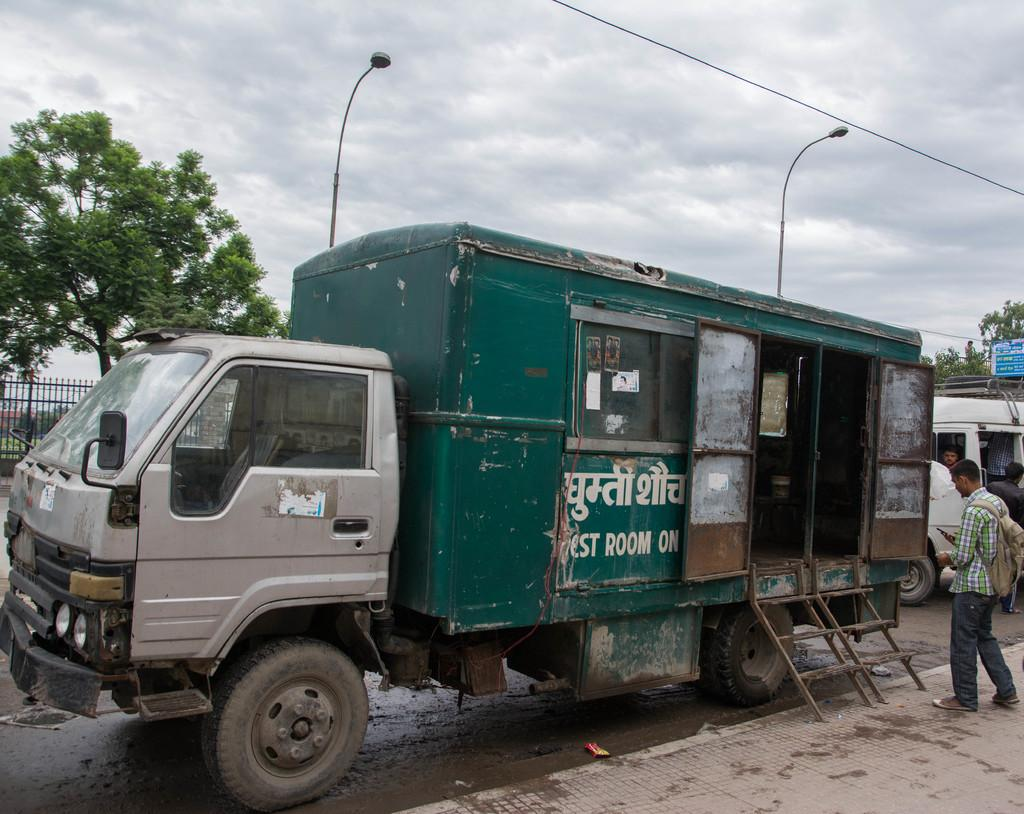What is the condition of the sky in the image? The sky is cloudy in the image. What structures can be seen along the road in the image? There are light poles in the image. What types of transportation are present on the road? Vehicles are present on the road. Can you identify any living beings in the image? People are visible in the image. What type of natural scenery is visible in the background? There are trees in the background. What type of barrier can be seen in the background? There is a fence in the background. What type of collar is visible on the light pole in the image? There is no collar present on the light pole in the image. 